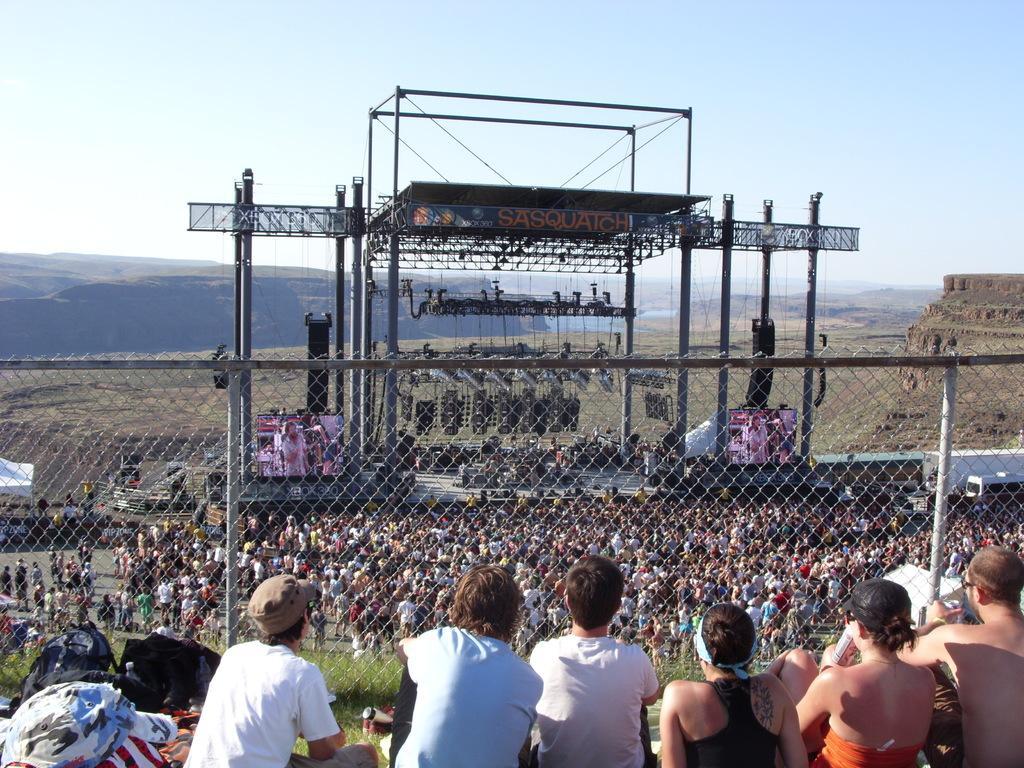In one or two sentences, can you explain what this image depicts? In this image there is a metal structure and a stage, on the left and right side of the stage there are screens, above the stage there are few focus lights, in front of the stage there are so many people and there is a net fence. At the bottom of the image there are a few people sitting. In the background there are mountains and the sky. 